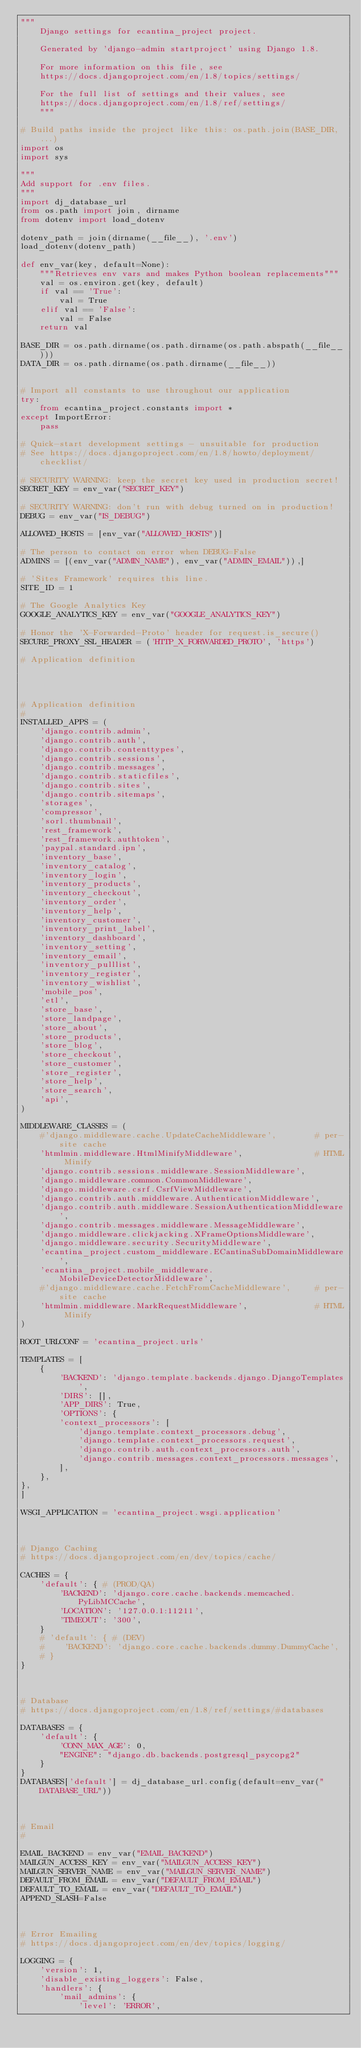Convert code to text. <code><loc_0><loc_0><loc_500><loc_500><_Python_>"""
    Django settings for ecantina_project project.

    Generated by 'django-admin startproject' using Django 1.8.

    For more information on this file, see
    https://docs.djangoproject.com/en/1.8/topics/settings/

    For the full list of settings and their values, see
    https://docs.djangoproject.com/en/1.8/ref/settings/
    """

# Build paths inside the project like this: os.path.join(BASE_DIR, ...)
import os
import sys

"""
Add support for .env files.
"""
import dj_database_url
from os.path import join, dirname
from dotenv import load_dotenv

dotenv_path = join(dirname(__file__), '.env')
load_dotenv(dotenv_path)

def env_var(key, default=None):
    """Retrieves env vars and makes Python boolean replacements"""
    val = os.environ.get(key, default)
    if val == 'True':
        val = True
    elif val == 'False':
        val = False
    return val

BASE_DIR = os.path.dirname(os.path.dirname(os.path.abspath(__file__)))
DATA_DIR = os.path.dirname(os.path.dirname(__file__))


# Import all constants to use throughout our application
try:
    from ecantina_project.constants import *
except ImportError:
    pass

# Quick-start development settings - unsuitable for production
# See https://docs.djangoproject.com/en/1.8/howto/deployment/checklist/

# SECURITY WARNING: keep the secret key used in production secret!
SECRET_KEY = env_var("SECRET_KEY")

# SECURITY WARNING: don't run with debug turned on in production!
DEBUG = env_var("IS_DEBUG")

ALLOWED_HOSTS = [env_var("ALLOWED_HOSTS")]

# The person to contact on error when DEBUG=False
ADMINS = [(env_var("ADMIN_NAME"), env_var("ADMIN_EMAIL")),]

# 'Sites Framework' requires this line.
SITE_ID = 1

# The Google Analytics Key
GOOGLE_ANALYTICS_KEY = env_var("GOOGLE_ANALYTICS_KEY")

# Honor the 'X-Forwarded-Proto' header for request.is_secure()
SECURE_PROXY_SSL_HEADER = ('HTTP_X_FORWARDED_PROTO', 'https')

# Application definition




# Application definition
#
INSTALLED_APPS = (
    'django.contrib.admin',
    'django.contrib.auth',
    'django.contrib.contenttypes',
    'django.contrib.sessions',
    'django.contrib.messages',
    'django.contrib.staticfiles',
    'django.contrib.sites',
    'django.contrib.sitemaps',
    'storages',
    'compressor',
    'sorl.thumbnail',
    'rest_framework',
    'rest_framework.authtoken',
    'paypal.standard.ipn',
    'inventory_base',
    'inventory_catalog',
    'inventory_login',
    'inventory_products',
    'inventory_checkout',
    'inventory_order',
    'inventory_help',
    'inventory_customer',
    'inventory_print_label',
    'inventory_dashboard',
    'inventory_setting',
    'inventory_email',
    'inventory_pulllist',
    'inventory_register',
    'inventory_wishlist',
    'mobile_pos',
    'etl',
    'store_base',
    'store_landpage',
    'store_about',
    'store_products',
    'store_blog',
    'store_checkout',
    'store_customer',
    'store_register',
    'store_help',
    'store_search',
    'api',
)

MIDDLEWARE_CLASSES = (
    #'django.middleware.cache.UpdateCacheMiddleware',        # per-site cache
    'htmlmin.middleware.HtmlMinifyMiddleware',               # HTML Minify
    'django.contrib.sessions.middleware.SessionMiddleware',
    'django.middleware.common.CommonMiddleware',
    'django.middleware.csrf.CsrfViewMiddleware',
    'django.contrib.auth.middleware.AuthenticationMiddleware',
    'django.contrib.auth.middleware.SessionAuthenticationMiddleware',
    'django.contrib.messages.middleware.MessageMiddleware',
    'django.middleware.clickjacking.XFrameOptionsMiddleware',
    'django.middleware.security.SecurityMiddleware',
    'ecantina_project.custom_middleware.ECantinaSubDomainMiddleware',
    'ecantina_project.mobile_middleware.MobileDeviceDetectorMiddleware',
    #'django.middleware.cache.FetchFromCacheMiddleware',     # per-site cache
    'htmlmin.middleware.MarkRequestMiddleware',              # HTML Minify
)

ROOT_URLCONF = 'ecantina_project.urls'

TEMPLATES = [
    {
        'BACKEND': 'django.template.backends.django.DjangoTemplates',
        'DIRS': [],
        'APP_DIRS': True,
        'OPTIONS': {
        'context_processors': [
            'django.template.context_processors.debug',
            'django.template.context_processors.request',
            'django.contrib.auth.context_processors.auth',
            'django.contrib.messages.context_processors.messages',
        ],
    },
},
]

WSGI_APPLICATION = 'ecantina_project.wsgi.application'



# Django Caching
# https://docs.djangoproject.com/en/dev/topics/cache/

CACHES = {
    'default': { # (PROD/QA)
        'BACKEND': 'django.core.cache.backends.memcached.PyLibMCCache',
        'LOCATION': '127.0.0.1:11211',
        'TIMEOUT': '300',
    }
    # 'default': { # (DEV)
    #    'BACKEND': 'django.core.cache.backends.dummy.DummyCache',
    # }
}



# Database
# https://docs.djangoproject.com/en/1.8/ref/settings/#databases

DATABASES = {
    'default': {
        'CONN_MAX_AGE': 0,
        "ENGINE": "django.db.backends.postgresql_psycopg2"
    }
}
DATABASES['default'] = dj_database_url.config(default=env_var("DATABASE_URL"))



# Email
#

EMAIL_BACKEND = env_var("EMAIL_BACKEND")
MAILGUN_ACCESS_KEY = env_var("MAILGUN_ACCESS_KEY")
MAILGUN_SERVER_NAME = env_var("MAILGUN_SERVER_NAME")
DEFAULT_FROM_EMAIL = env_var("DEFAULT_FROM_EMAIL")
DEFAULT_TO_EMAIL = env_var("DEFAULT_TO_EMAIL")
APPEND_SLASH=False



# Error Emailing
# https://docs.djangoproject.com/en/dev/topics/logging/

LOGGING = {
    'version': 1,
    'disable_existing_loggers': False,
    'handlers': {
        'mail_admins': {
            'level': 'ERROR',</code> 